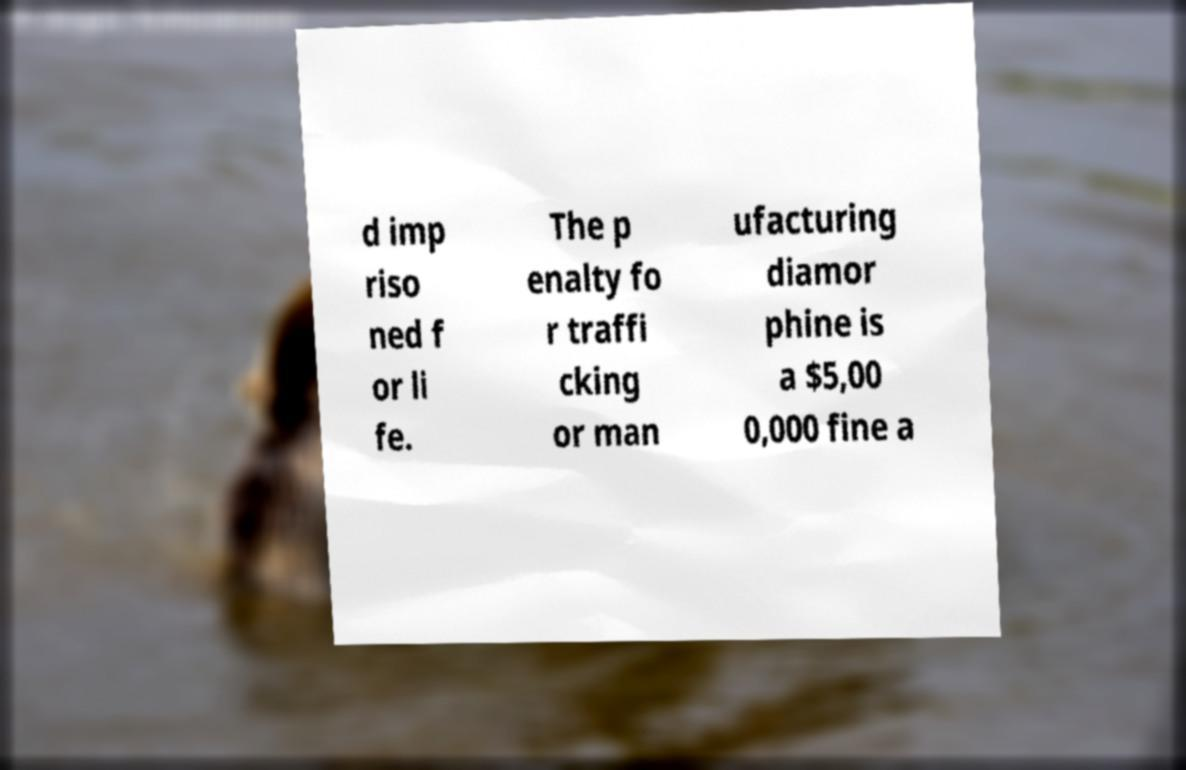Can you read and provide the text displayed in the image?This photo seems to have some interesting text. Can you extract and type it out for me? d imp riso ned f or li fe. The p enalty fo r traffi cking or man ufacturing diamor phine is a $5,00 0,000 fine a 